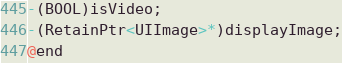<code> <loc_0><loc_0><loc_500><loc_500><_C_>-(BOOL)isVideo;
-(RetainPtr<UIImage>*)displayImage;
@end

</code> 